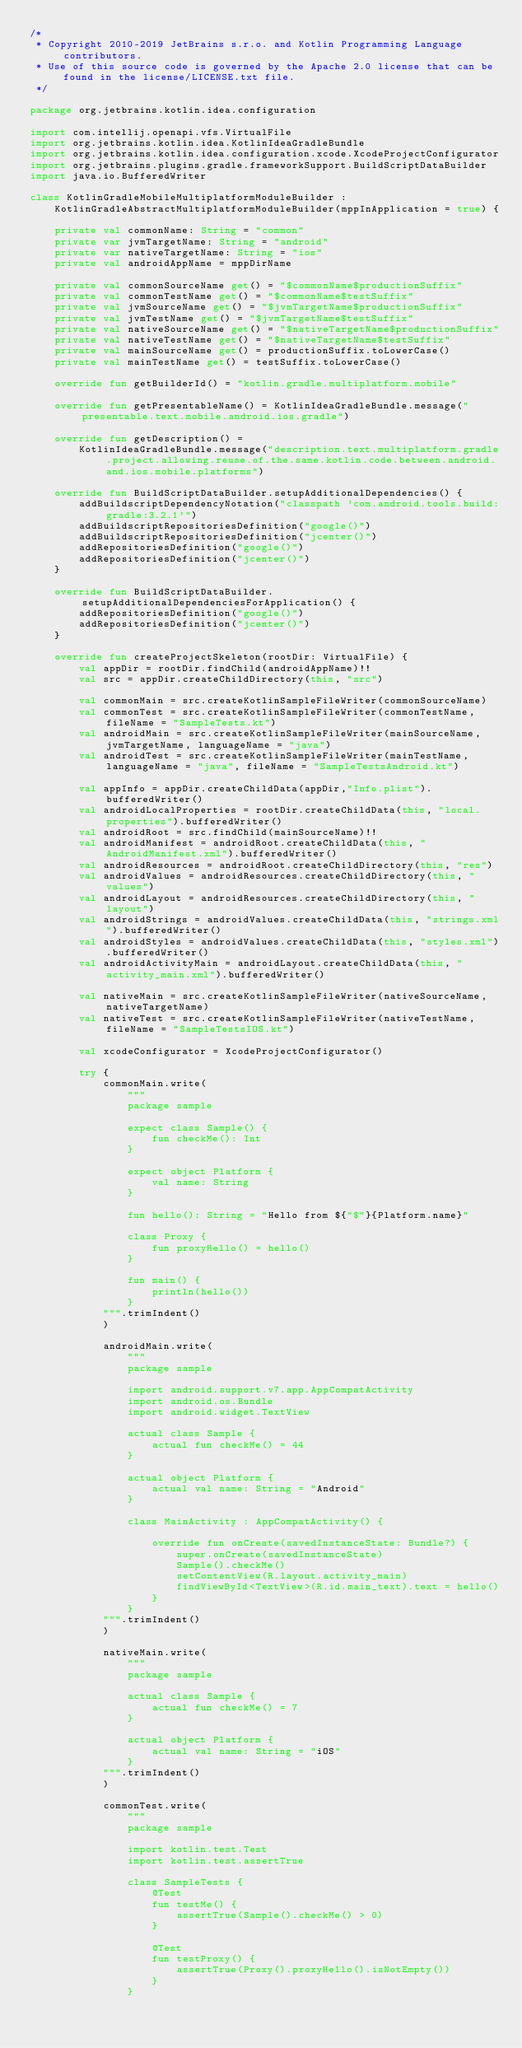<code> <loc_0><loc_0><loc_500><loc_500><_Kotlin_>/*
 * Copyright 2010-2019 JetBrains s.r.o. and Kotlin Programming Language contributors.
 * Use of this source code is governed by the Apache 2.0 license that can be found in the license/LICENSE.txt file.
 */

package org.jetbrains.kotlin.idea.configuration

import com.intellij.openapi.vfs.VirtualFile
import org.jetbrains.kotlin.idea.KotlinIdeaGradleBundle
import org.jetbrains.kotlin.idea.configuration.xcode.XcodeProjectConfigurator
import org.jetbrains.plugins.gradle.frameworkSupport.BuildScriptDataBuilder
import java.io.BufferedWriter

class KotlinGradleMobileMultiplatformModuleBuilder :
    KotlinGradleAbstractMultiplatformModuleBuilder(mppInApplication = true) {

    private val commonName: String = "common"
    private var jvmTargetName: String = "android"
    private var nativeTargetName: String = "ios"
    private val androidAppName = mppDirName

    private val commonSourceName get() = "$commonName$productionSuffix"
    private val commonTestName get() = "$commonName$testSuffix"
    private val jvmSourceName get() = "$jvmTargetName$productionSuffix"
    private val jvmTestName get() = "$jvmTargetName$testSuffix"
    private val nativeSourceName get() = "$nativeTargetName$productionSuffix"
    private val nativeTestName get() = "$nativeTargetName$testSuffix"
    private val mainSourceName get() = productionSuffix.toLowerCase()
    private val mainTestName get() = testSuffix.toLowerCase()

    override fun getBuilderId() = "kotlin.gradle.multiplatform.mobile"

    override fun getPresentableName() = KotlinIdeaGradleBundle.message("presentable.text.mobile.android.ios.gradle")

    override fun getDescription() =
        KotlinIdeaGradleBundle.message("description.text.multiplatform.gradle.project.allowing.reuse.of.the.same.kotlin.code.between.android.and.ios.mobile.platforms")

    override fun BuildScriptDataBuilder.setupAdditionalDependencies() {
        addBuildscriptDependencyNotation("classpath 'com.android.tools.build:gradle:3.2.1'")
        addBuildscriptRepositoriesDefinition("google()")
        addBuildscriptRepositoriesDefinition("jcenter()")
        addRepositoriesDefinition("google()")
        addRepositoriesDefinition("jcenter()")
    }

    override fun BuildScriptDataBuilder.setupAdditionalDependenciesForApplication() {
        addRepositoriesDefinition("google()")
        addRepositoriesDefinition("jcenter()")
    }

    override fun createProjectSkeleton(rootDir: VirtualFile) {
        val appDir = rootDir.findChild(androidAppName)!!
        val src = appDir.createChildDirectory(this, "src")

        val commonMain = src.createKotlinSampleFileWriter(commonSourceName)
        val commonTest = src.createKotlinSampleFileWriter(commonTestName, fileName = "SampleTests.kt")
        val androidMain = src.createKotlinSampleFileWriter(mainSourceName, jvmTargetName, languageName = "java")
        val androidTest = src.createKotlinSampleFileWriter(mainTestName, languageName = "java", fileName = "SampleTestsAndroid.kt")

        val appInfo = appDir.createChildData(appDir,"Info.plist").bufferedWriter()
        val androidLocalProperties = rootDir.createChildData(this, "local.properties").bufferedWriter()
        val androidRoot = src.findChild(mainSourceName)!!
        val androidManifest = androidRoot.createChildData(this, "AndroidManifest.xml").bufferedWriter()
        val androidResources = androidRoot.createChildDirectory(this, "res")
        val androidValues = androidResources.createChildDirectory(this, "values")
        val androidLayout = androidResources.createChildDirectory(this, "layout")
        val androidStrings = androidValues.createChildData(this, "strings.xml").bufferedWriter()
        val androidStyles = androidValues.createChildData(this, "styles.xml").bufferedWriter()
        val androidActivityMain = androidLayout.createChildData(this, "activity_main.xml").bufferedWriter()

        val nativeMain = src.createKotlinSampleFileWriter(nativeSourceName, nativeTargetName)
        val nativeTest = src.createKotlinSampleFileWriter(nativeTestName, fileName = "SampleTestsIOS.kt")

        val xcodeConfigurator = XcodeProjectConfigurator()

        try {
            commonMain.write(
                """
                package sample

                expect class Sample() {
                    fun checkMe(): Int
                }

                expect object Platform {
                    val name: String
                }

                fun hello(): String = "Hello from ${"$"}{Platform.name}"

                class Proxy {
                    fun proxyHello() = hello()
                }

                fun main() {
                    println(hello())
                }
            """.trimIndent()
            )

            androidMain.write(
                """
                package sample

                import android.support.v7.app.AppCompatActivity
                import android.os.Bundle
                import android.widget.TextView

                actual class Sample {
                    actual fun checkMe() = 44
                }

                actual object Platform {
                    actual val name: String = "Android"
                }

                class MainActivity : AppCompatActivity() {

                    override fun onCreate(savedInstanceState: Bundle?) {
                        super.onCreate(savedInstanceState)
                        Sample().checkMe()
                        setContentView(R.layout.activity_main)
                        findViewById<TextView>(R.id.main_text).text = hello()
                    }
                }
            """.trimIndent()
            )

            nativeMain.write(
                """
                package sample

                actual class Sample {
                    actual fun checkMe() = 7
                }

                actual object Platform {
                    actual val name: String = "iOS"
                }
            """.trimIndent()
            )

            commonTest.write(
                """
                package sample

                import kotlin.test.Test
                import kotlin.test.assertTrue

                class SampleTests {
                    @Test
                    fun testMe() {
                        assertTrue(Sample().checkMe() > 0)
                    }

                    @Test
                    fun testProxy() {
                        assertTrue(Proxy().proxyHello().isNotEmpty())
                    }
                }</code> 